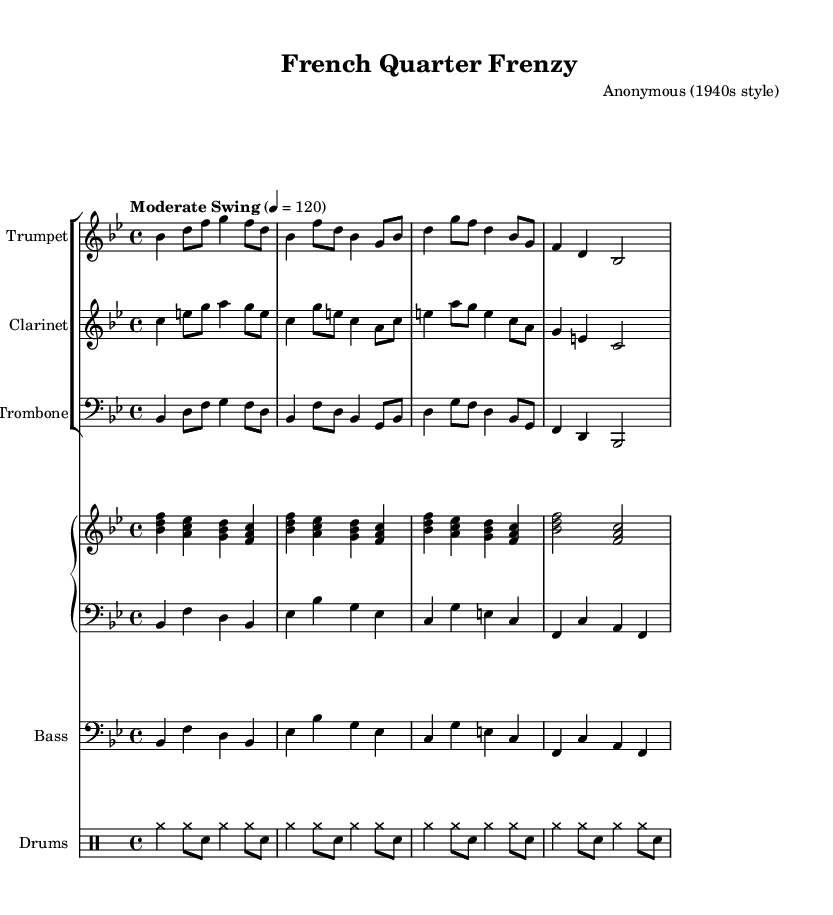What is the key signature of this music? The key signature shows two flats (B♭ and E♭), indicating that the piece is in B♭ major.
Answer: B♭ major What is the time signature of the piece? The time signature, shown at the beginning of the score, is 4/4, meaning there are four beats in each measure.
Answer: 4/4 What is the tempo marking given in the sheet music? The tempo marking indicates "Moderate Swing" and it is set at a quarter note equals 120 beats per minute.
Answer: Moderate Swing, 120 How many instruments are featured in this score? There are five distinct instruments indicated in the score: trumpet, clarinet, trombone, piano (with right and left hands), and bass, along with drums.
Answer: Five Which instrument plays in the bass clef? The Trombone and Bass parts are written in the bass clef, as indicated at the beginning of their respective staves.
Answer: Trombone and Bass What characterizes the style of music represented in the score? The upbeat rhythms, syncopation, and use of collective improvisation reflect characteristics of New Orleans jazz from the 1940s.
Answer: New Orleans jazz 